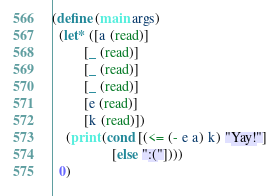Convert code to text. <code><loc_0><loc_0><loc_500><loc_500><_Scheme_>(define (main args)
  (let* ([a (read)]
         [_ (read)]
         [_ (read)]
         [_ (read)]
         [e (read)]
         [k (read)])
    (print (cond [(<= (- e a) k) "Yay!"]
                 [else ":("])))
  0)
</code> 